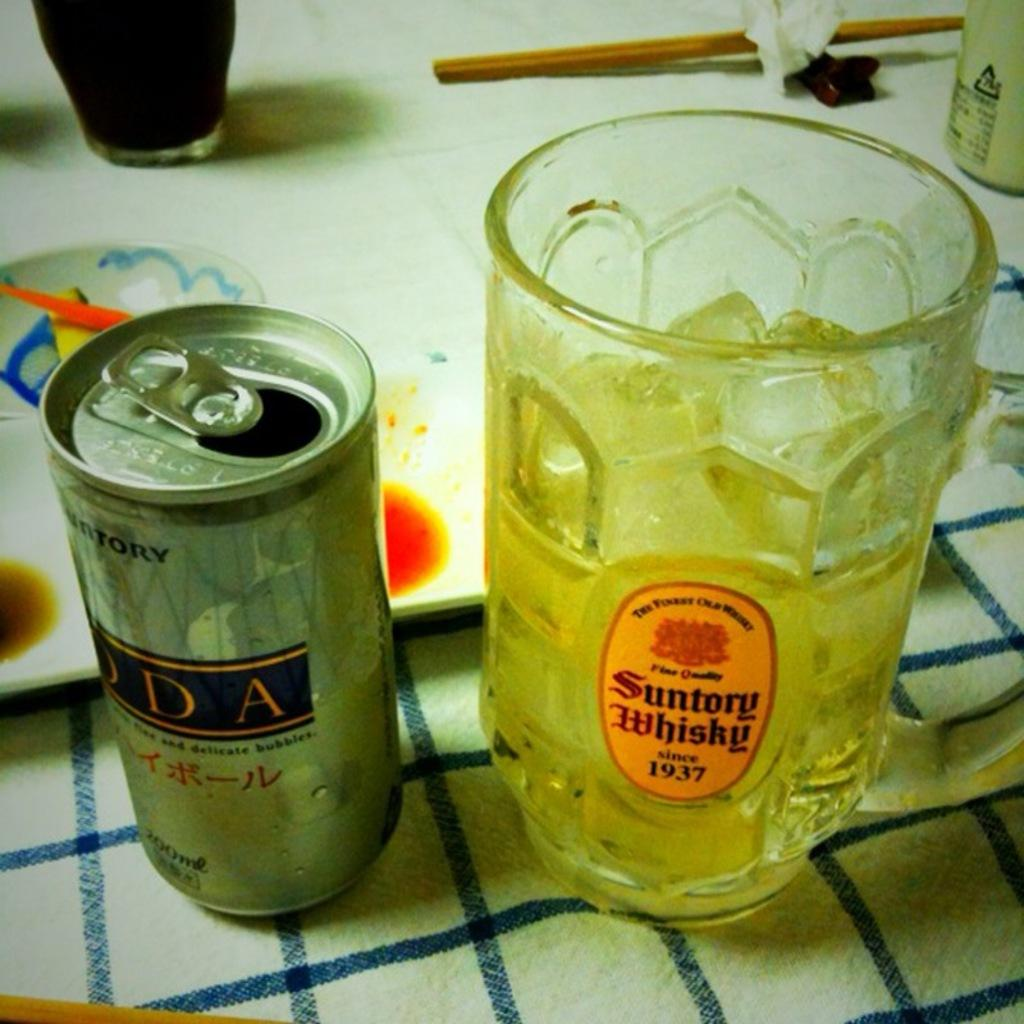<image>
Create a compact narrative representing the image presented. A silver beverage can is open next to a half empty glass with the name Suntory Whiskey on the front. 